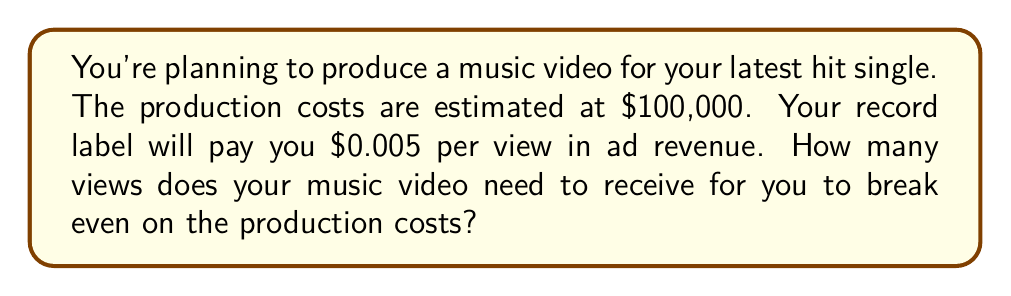Can you solve this math problem? Let's approach this step-by-step:

1) First, let's define our variables:
   $x$ = number of views needed to break even
   $c$ = production cost = $100,000
   $r$ = revenue per view = $0.005

2) At the break-even point, the revenue equals the cost. We can express this as an equation:

   $rx = c$

3) Substituting our known values:

   $0.005x = 100,000$

4) To solve for $x$, we divide both sides by 0.005:

   $x = \frac{100,000}{0.005}$

5) Simplify:
   
   $x = 20,000,000$

Therefore, you need 20,000,000 views to break even on your music video production costs.
Answer: 20,000,000 views 